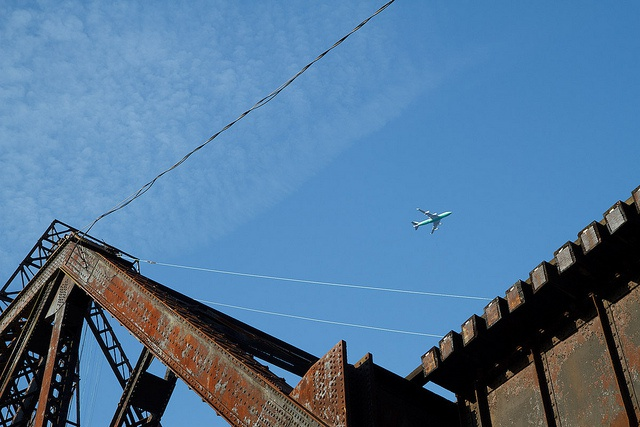Describe the objects in this image and their specific colors. I can see a airplane in gray, blue, and white tones in this image. 